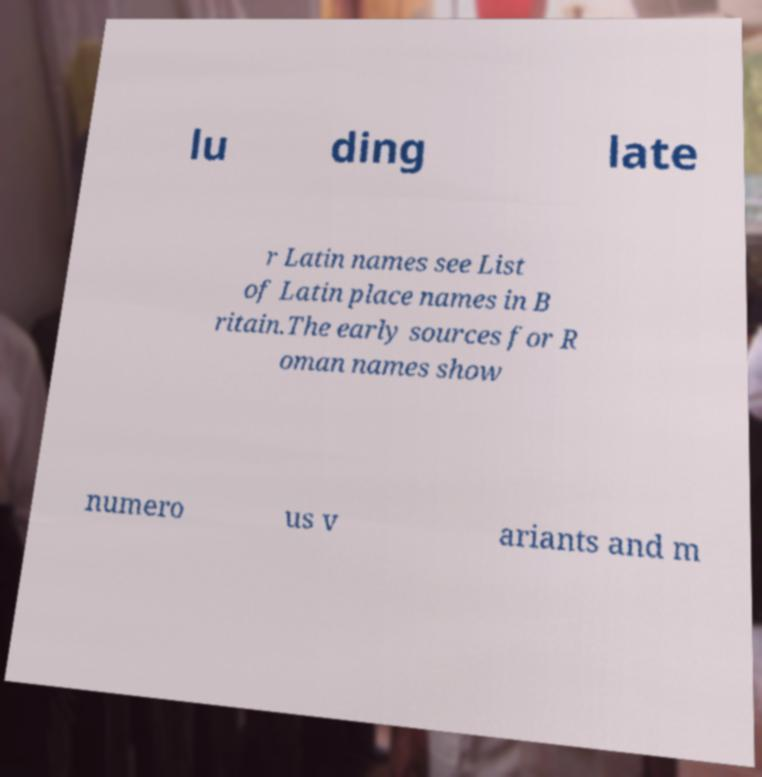Can you accurately transcribe the text from the provided image for me? lu ding late r Latin names see List of Latin place names in B ritain.The early sources for R oman names show numero us v ariants and m 